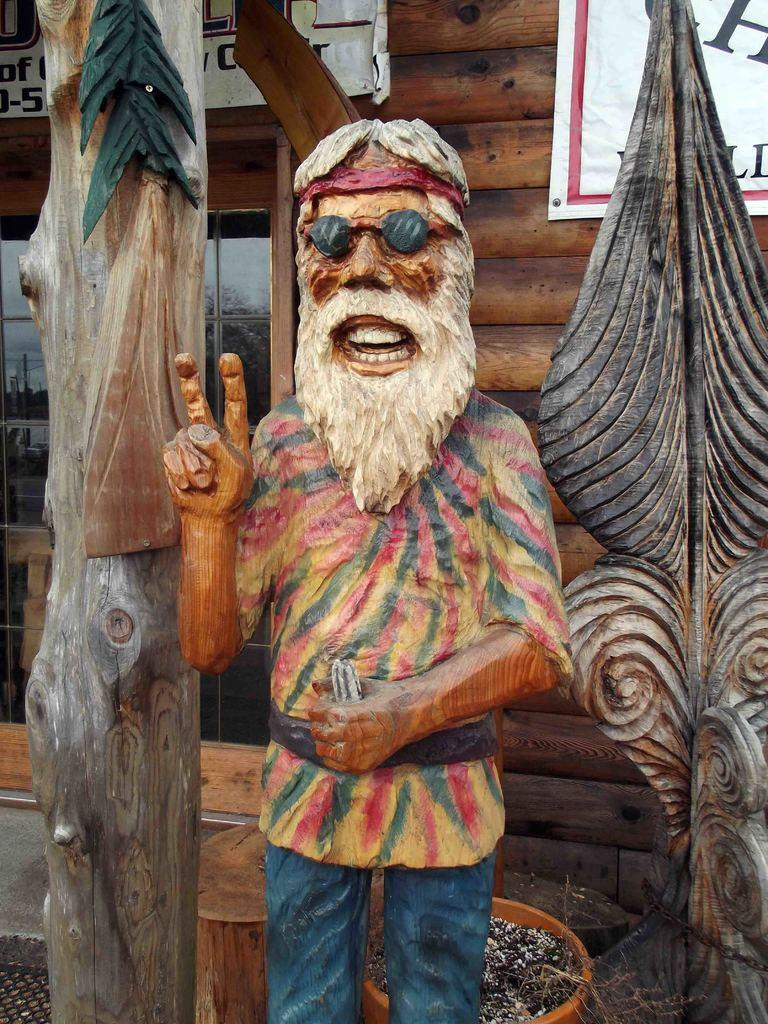What type of objects can be seen in the image? There are wooden decorative objects in the image. What else is present in the image besides the wooden objects? There is a pot in the image. What can be seen in the background of the image? The background of the image includes a wooden wall, posters, and a glass window. What is visible on the glass window? Reflections are visible on the glass window. How many nuts are being held by the beast in the image? There is no beast or nuts present in the image. What type of spiders can be seen crawling on the wooden wall in the image? There are no spiders visible on the wooden wall in the image. 